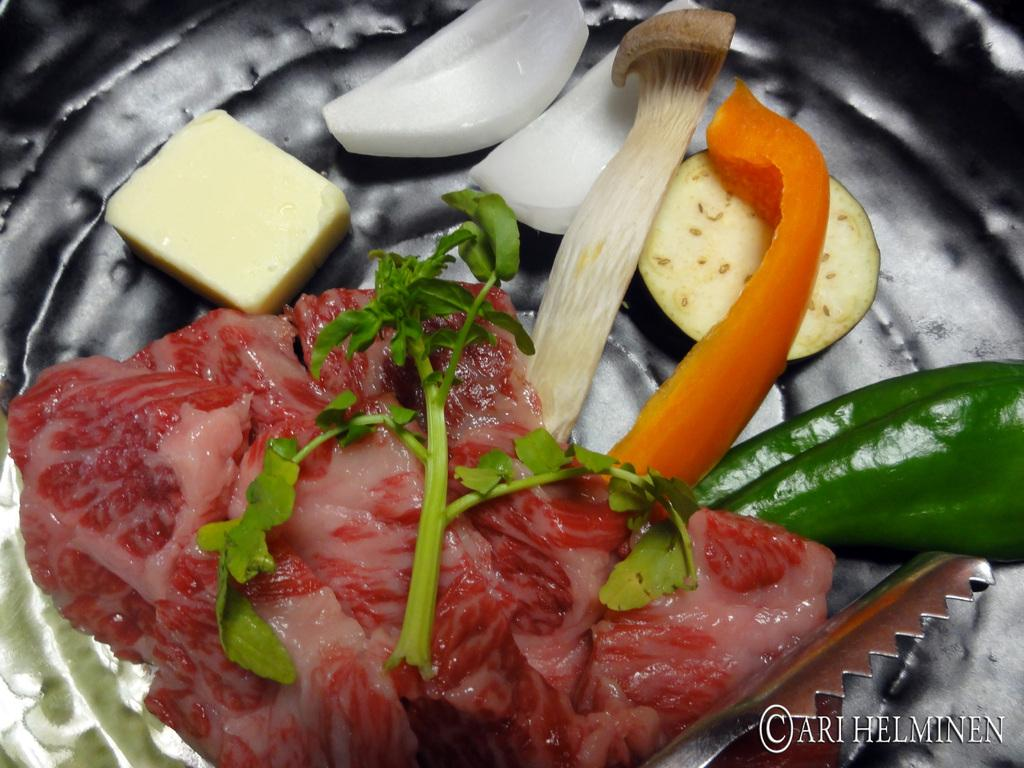What is on the plate in the image? There are food items on a plate in the image. Can you describe the steel object at the bottom right side of the image? There is a steel object at the bottom right side of the image. Is there any additional information about the image itself? Yes, there is a watermark on the image. Are there any fairies flying around the food items in the image? No, there are no fairies present in the image. What type of cap is the bat wearing in the image? There is no bat or cap present in the image. 